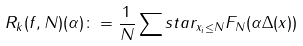Convert formula to latex. <formula><loc_0><loc_0><loc_500><loc_500>R _ { k } ( f , N ) ( \alpha ) \colon = \frac { 1 } { N } \sum s t a r _ { x _ { i } \leq N } F _ { N } ( \alpha \Delta ( x ) )</formula> 